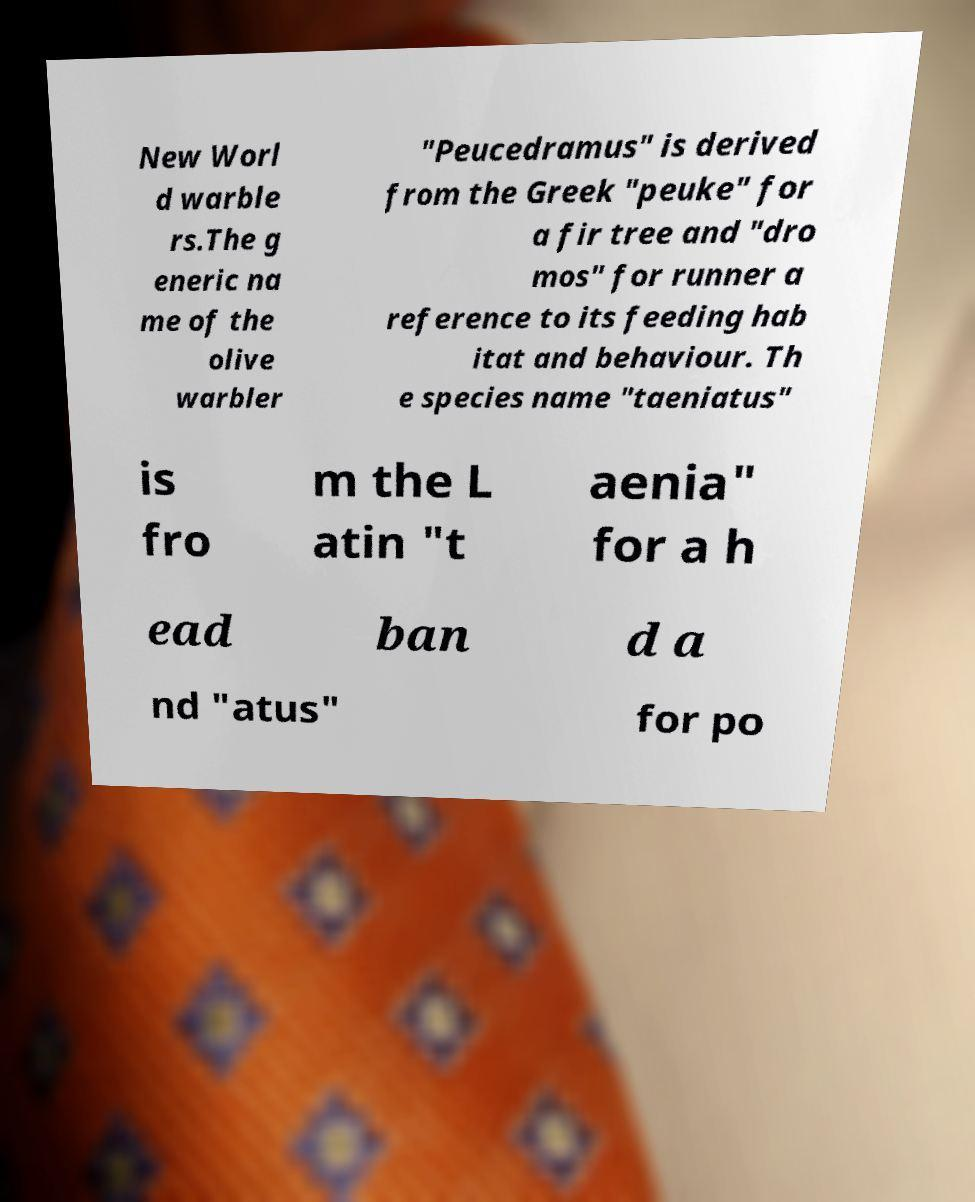For documentation purposes, I need the text within this image transcribed. Could you provide that? New Worl d warble rs.The g eneric na me of the olive warbler "Peucedramus" is derived from the Greek "peuke" for a fir tree and "dro mos" for runner a reference to its feeding hab itat and behaviour. Th e species name "taeniatus" is fro m the L atin "t aenia" for a h ead ban d a nd "atus" for po 